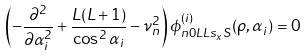<formula> <loc_0><loc_0><loc_500><loc_500>\left ( - \frac { \partial ^ { 2 } } { \partial \alpha _ { i } ^ { 2 } } + \frac { L ( L + 1 ) } { \cos ^ { 2 } \alpha _ { i } } - \nu ^ { 2 } _ { n } \right ) \phi _ { n 0 L L s _ { x } S } ^ { ( i ) } ( \rho , \alpha _ { i } ) = 0 \,</formula> 